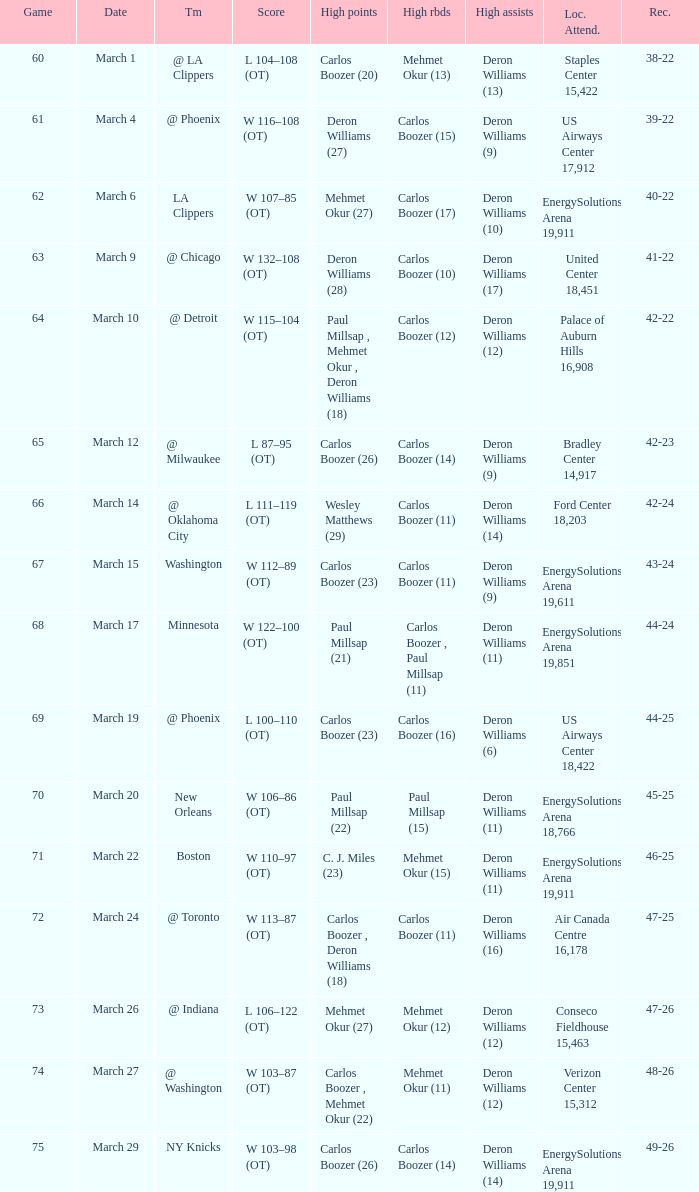Where was the March 24 game played? Air Canada Centre 16,178. 